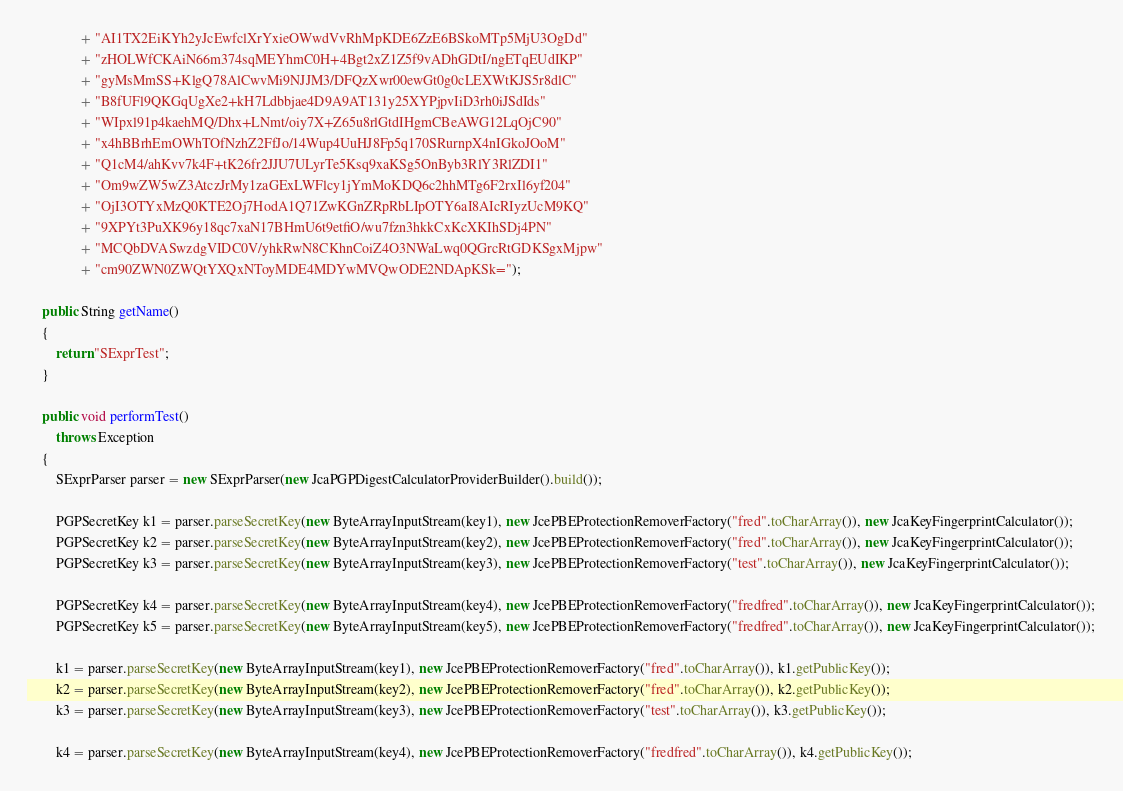Convert code to text. <code><loc_0><loc_0><loc_500><loc_500><_Java_>               + "AI1TX2EiKYh2yJcEwfclXrYxieOWwdVvRhMpKDE6ZzE6BSkoMTp5MjU3OgDd"
               + "zHOLWfCKAiN66m374sqMEYhmC0H+4Bgt2xZ1Z5f9vADhGDtI/ngETqEUdIKP"
               + "gyMsMmSS+KlgQ78AlCwvMi9NJJM3/DFQzXwr00ewGt0g0cLEXWtKJS5r8dlC"
               + "B8fUFl9QKGqUgXe2+kH7Ldbbjae4D9A9AT131y25XYPjpvIiD3rh0iJSdIds"
               + "WIpxl91p4kaehMQ/Dhx+LNmt/oiy7X+Z65u8rlGtdIHgmCBeAWG12LqOjC90"
               + "x4hBBrhEmOWhTOfNzhZ2FfJo/14Wup4UuHJ8Fp5q170SRurnpX4nIGkoJOoM"
               + "Q1cM4/ahKvv7k4F+tK26fr2JJU7ULyrTe5Ksq9xaKSg5OnByb3RlY3RlZDI1"
               + "Om9wZW5wZ3AtczJrMy1zaGExLWFlcy1jYmMoKDQ6c2hhMTg6F2rxIl6yf204"
               + "OjI3OTYxMzQ0KTE2Oj7HodA1Q71ZwKGnZRpRbLIpOTY6aI8AIcRIyzUcM9KQ"
               + "9XPYt3PuXK96y18qc7xaN17BHmU6t9etfiO/wu7fzn3hkkCxKcXKIhSDj4PN"
               + "MCQbDVASwzdgVIDC0V/yhkRwN8CKhnCoiZ4O3NWaLwq0QGrcRtGDKSgxMjpw"
               + "cm90ZWN0ZWQtYXQxNToyMDE4MDYwMVQwODE2NDApKSk=");

    public String getName()
    {
        return "SExprTest";
    }

    public void performTest()
        throws Exception
    {
        SExprParser parser = new SExprParser(new JcaPGPDigestCalculatorProviderBuilder().build());

        PGPSecretKey k1 = parser.parseSecretKey(new ByteArrayInputStream(key1), new JcePBEProtectionRemoverFactory("fred".toCharArray()), new JcaKeyFingerprintCalculator());
        PGPSecretKey k2 = parser.parseSecretKey(new ByteArrayInputStream(key2), new JcePBEProtectionRemoverFactory("fred".toCharArray()), new JcaKeyFingerprintCalculator());
        PGPSecretKey k3 = parser.parseSecretKey(new ByteArrayInputStream(key3), new JcePBEProtectionRemoverFactory("test".toCharArray()), new JcaKeyFingerprintCalculator());

        PGPSecretKey k4 = parser.parseSecretKey(new ByteArrayInputStream(key4), new JcePBEProtectionRemoverFactory("fredfred".toCharArray()), new JcaKeyFingerprintCalculator());
        PGPSecretKey k5 = parser.parseSecretKey(new ByteArrayInputStream(key5), new JcePBEProtectionRemoverFactory("fredfred".toCharArray()), new JcaKeyFingerprintCalculator());

        k1 = parser.parseSecretKey(new ByteArrayInputStream(key1), new JcePBEProtectionRemoverFactory("fred".toCharArray()), k1.getPublicKey());
        k2 = parser.parseSecretKey(new ByteArrayInputStream(key2), new JcePBEProtectionRemoverFactory("fred".toCharArray()), k2.getPublicKey());
        k3 = parser.parseSecretKey(new ByteArrayInputStream(key3), new JcePBEProtectionRemoverFactory("test".toCharArray()), k3.getPublicKey());

        k4 = parser.parseSecretKey(new ByteArrayInputStream(key4), new JcePBEProtectionRemoverFactory("fredfred".toCharArray()), k4.getPublicKey());</code> 